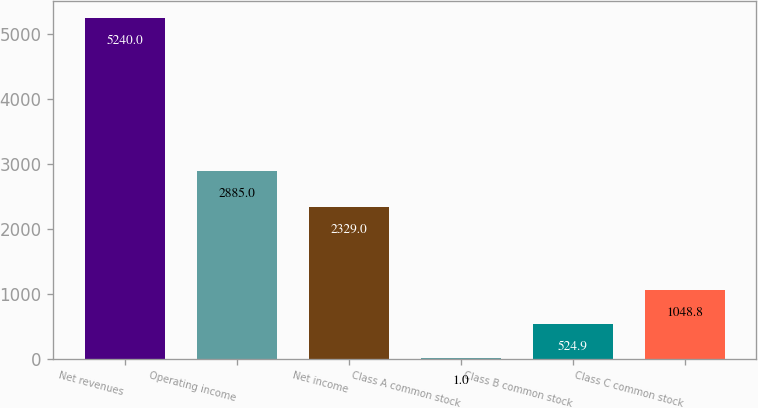Convert chart to OTSL. <chart><loc_0><loc_0><loc_500><loc_500><bar_chart><fcel>Net revenues<fcel>Operating income<fcel>Net income<fcel>Class A common stock<fcel>Class B common stock<fcel>Class C common stock<nl><fcel>5240<fcel>2885<fcel>2329<fcel>1<fcel>524.9<fcel>1048.8<nl></chart> 